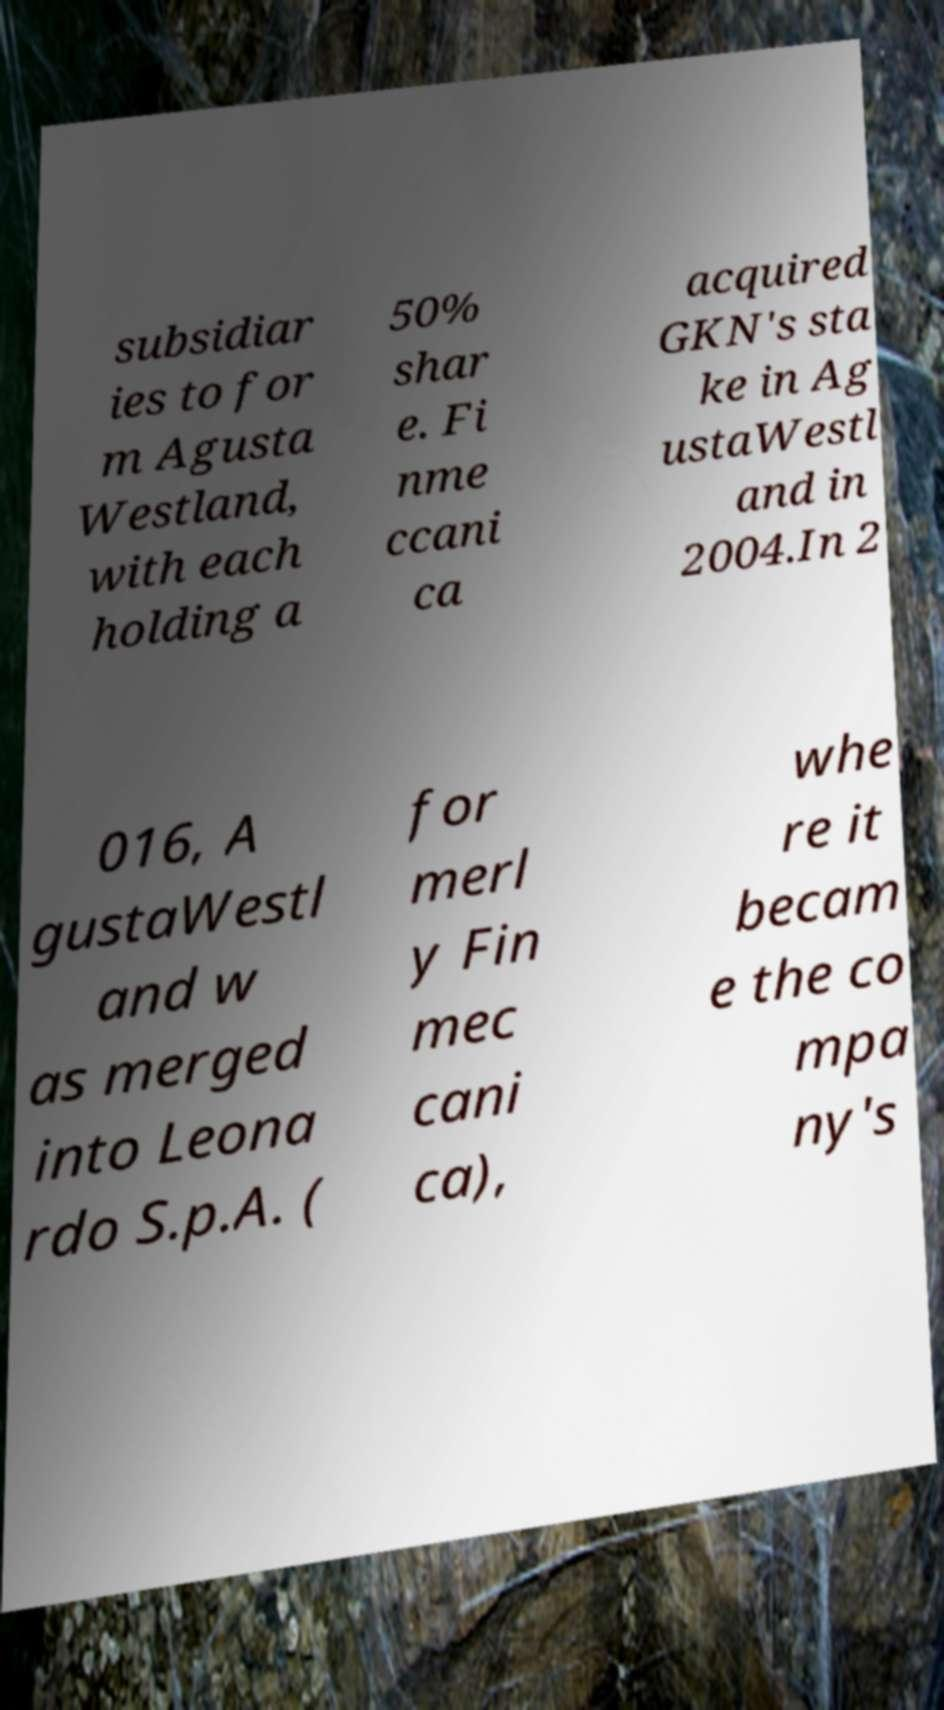Can you read and provide the text displayed in the image?This photo seems to have some interesting text. Can you extract and type it out for me? subsidiar ies to for m Agusta Westland, with each holding a 50% shar e. Fi nme ccani ca acquired GKN's sta ke in Ag ustaWestl and in 2004.In 2 016, A gustaWestl and w as merged into Leona rdo S.p.A. ( for merl y Fin mec cani ca), whe re it becam e the co mpa ny's 